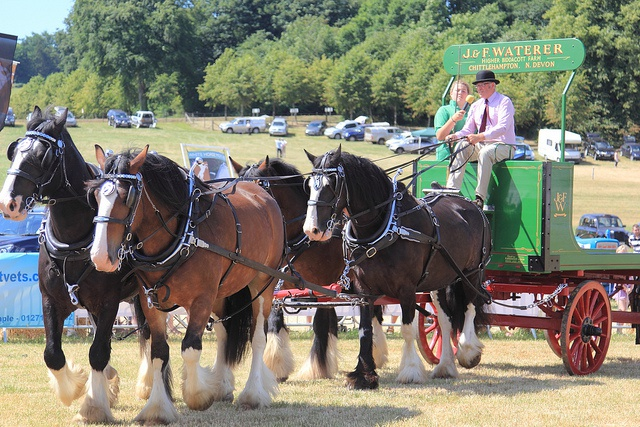Describe the objects in this image and their specific colors. I can see horse in lightblue, black, gray, maroon, and darkgray tones, horse in lightblue, black, darkgray, and gray tones, horse in lightblue, black, gray, darkgray, and white tones, horse in lightblue, black, darkgray, gray, and maroon tones, and people in lightblue, white, darkgray, violet, and gray tones in this image. 